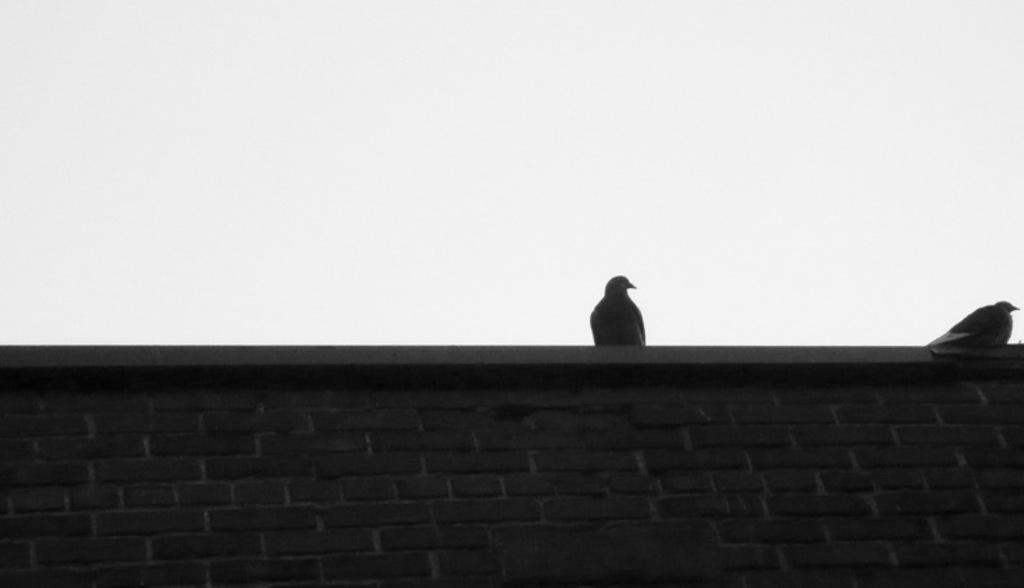Describe this image in one or two sentences. This image consists of two birds on the wall. At the bottom, we can see a wall made up of bricks. In the background, there is sky. 